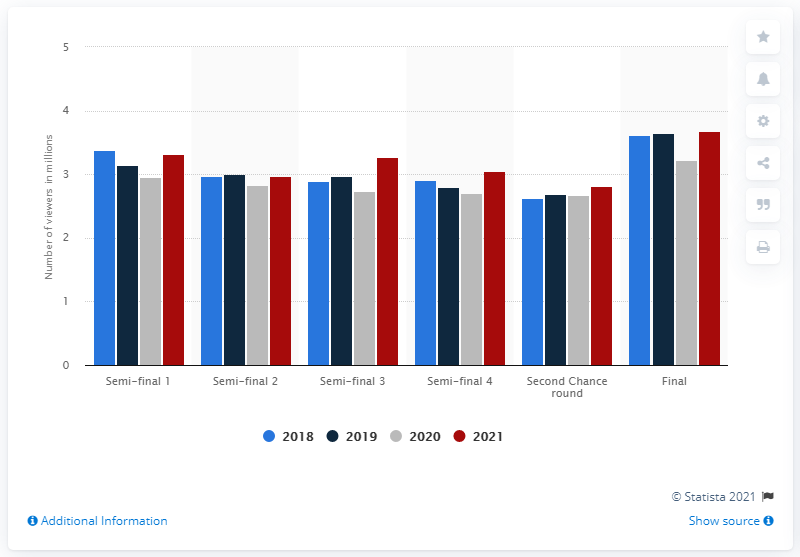List a handful of essential elements in this visual. In 2021, the Melodifestivalen final was watched by 3.65 people. 